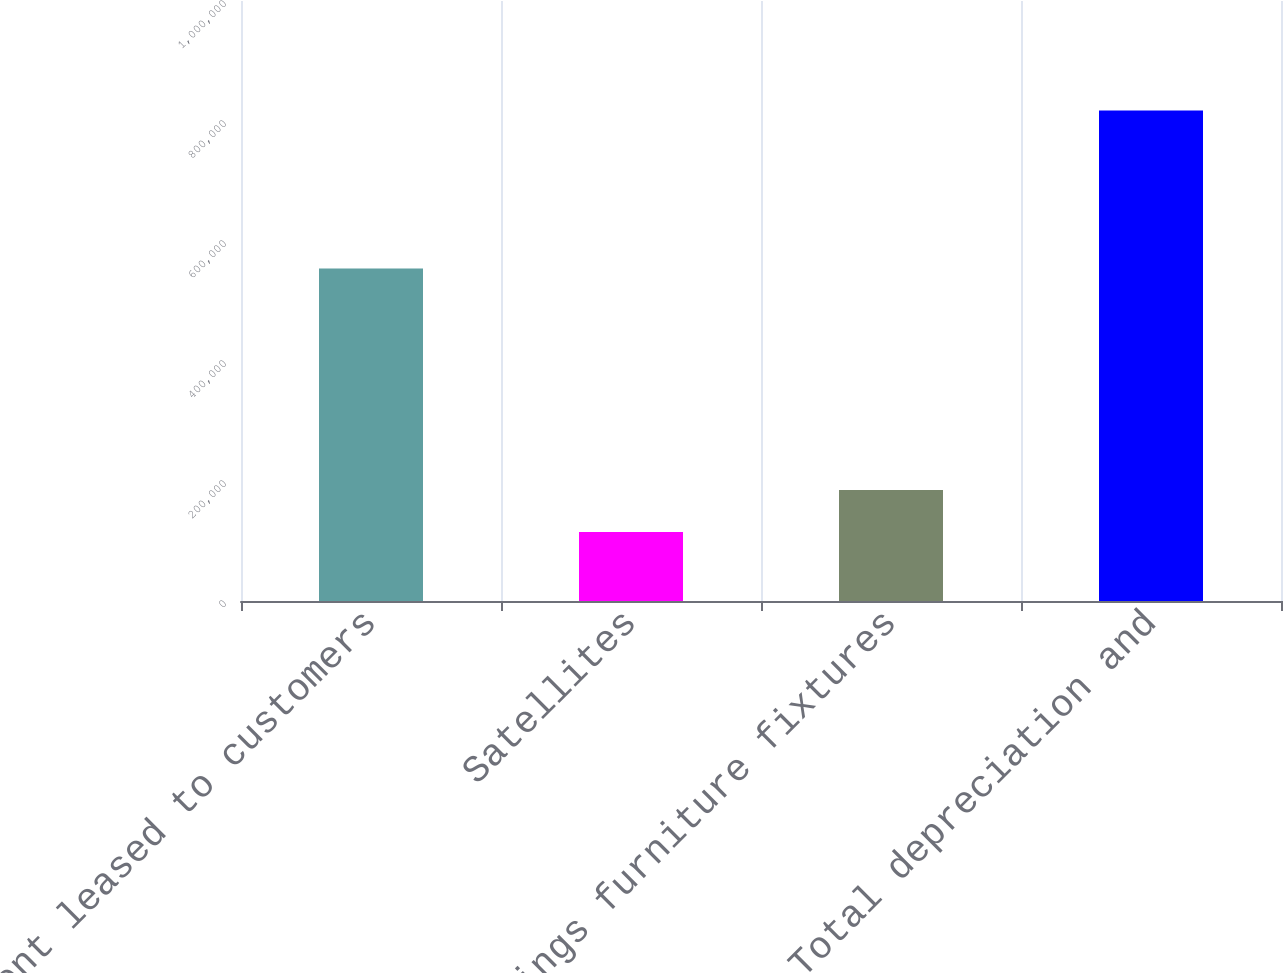<chart> <loc_0><loc_0><loc_500><loc_500><bar_chart><fcel>Equipment leased to customers<fcel>Satellites<fcel>Buildings furniture fixtures<fcel>Total depreciation and<nl><fcel>554272<fcel>114821<fcel>185095<fcel>817564<nl></chart> 